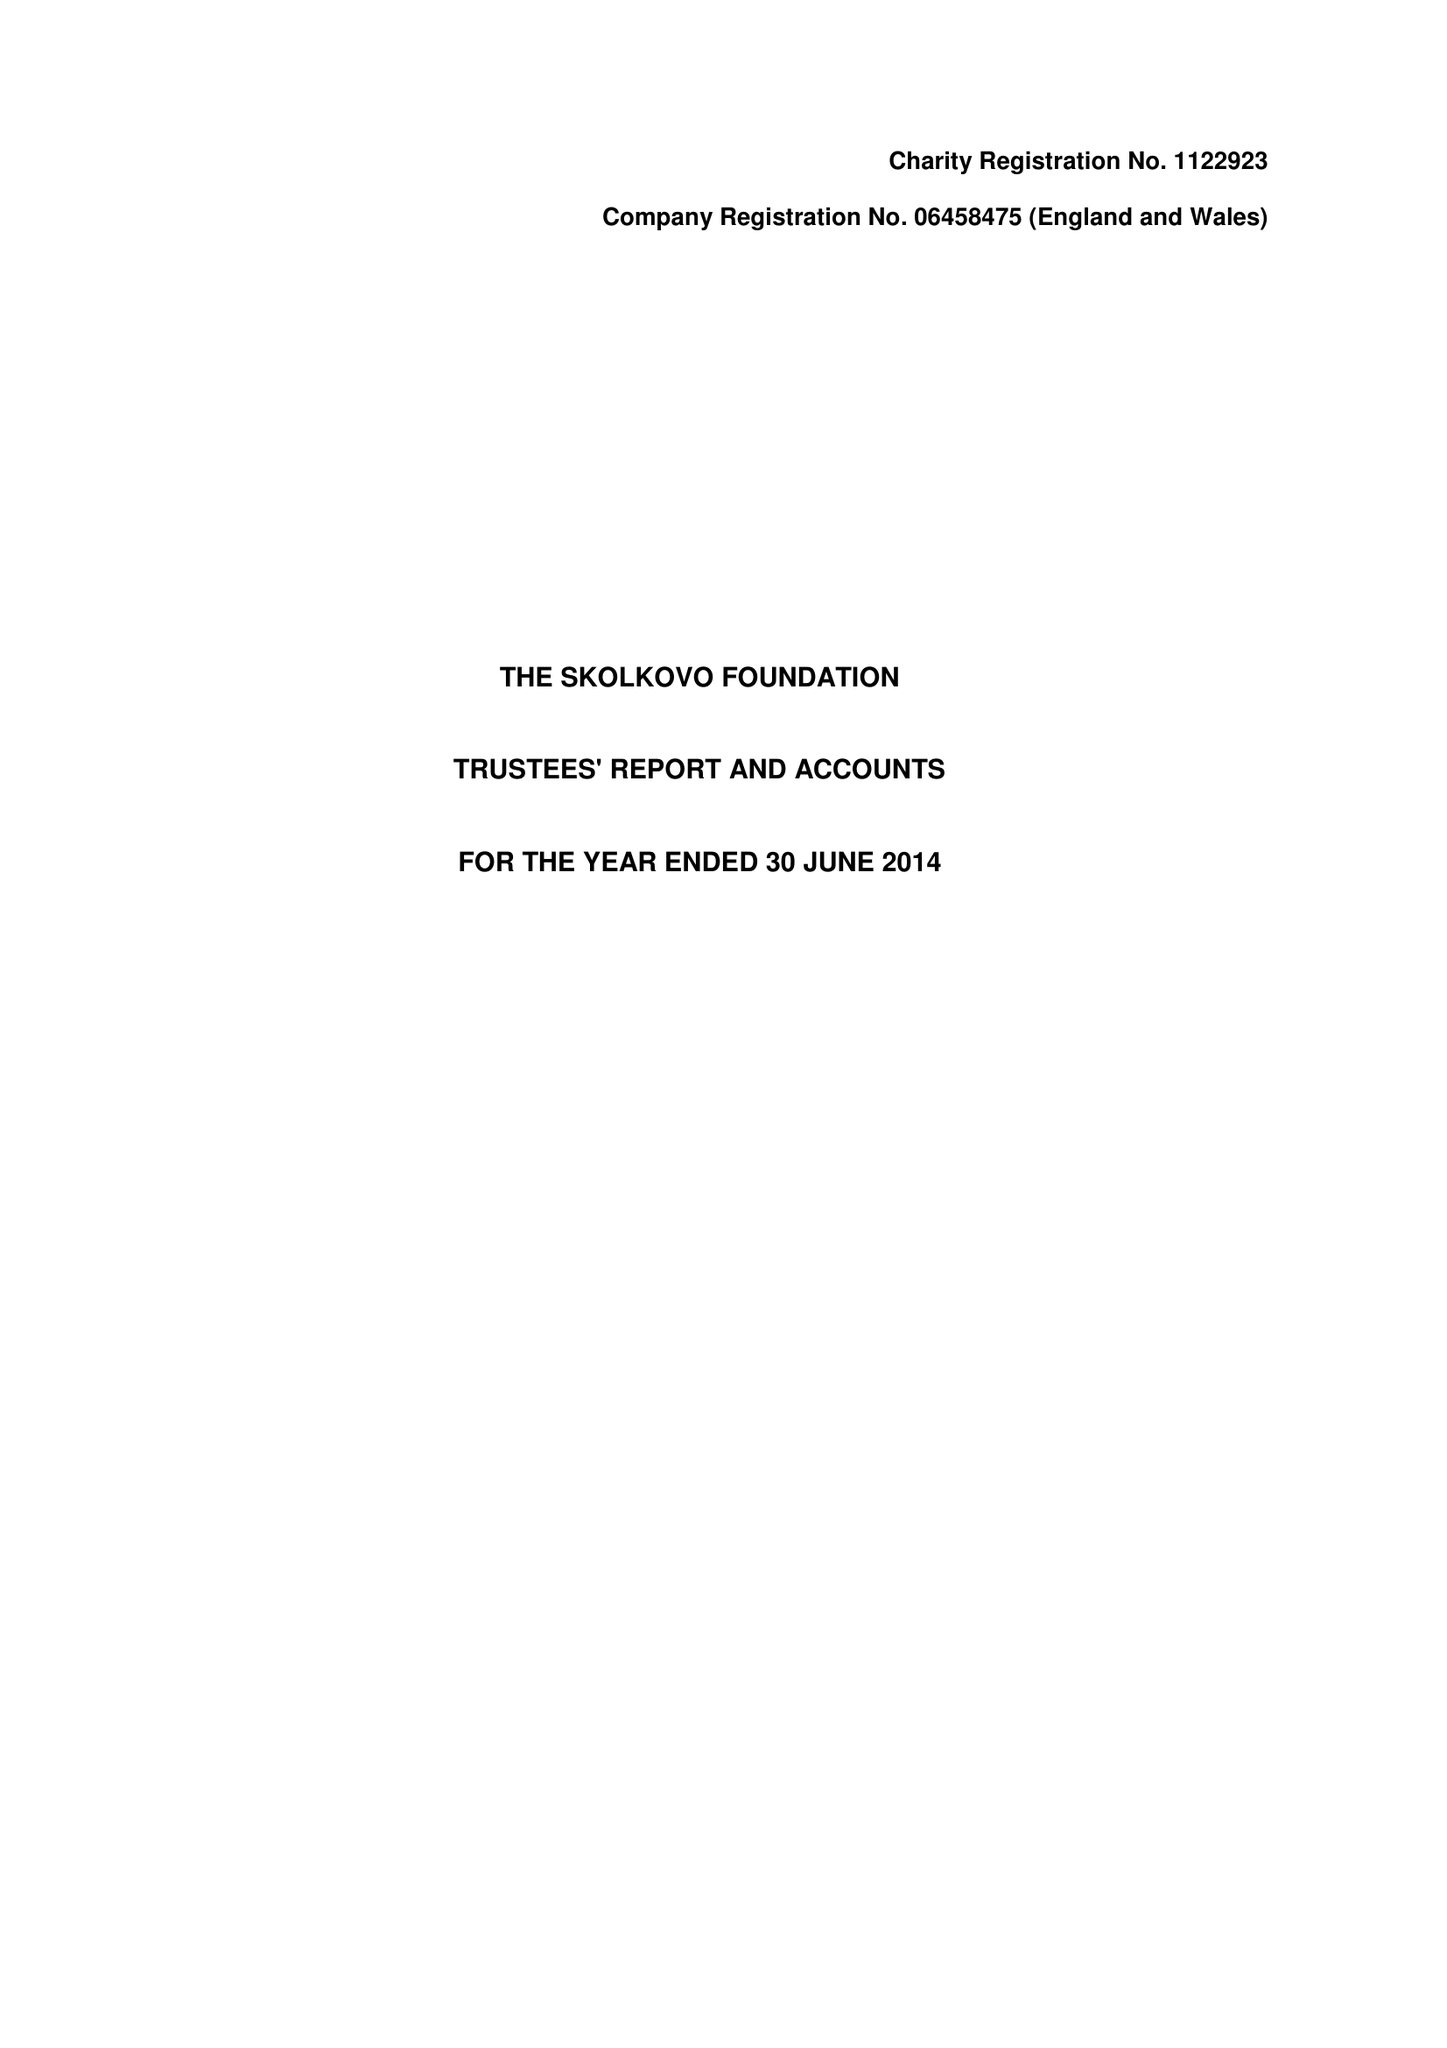What is the value for the address__post_town?
Answer the question using a single word or phrase. WEST MALLING 